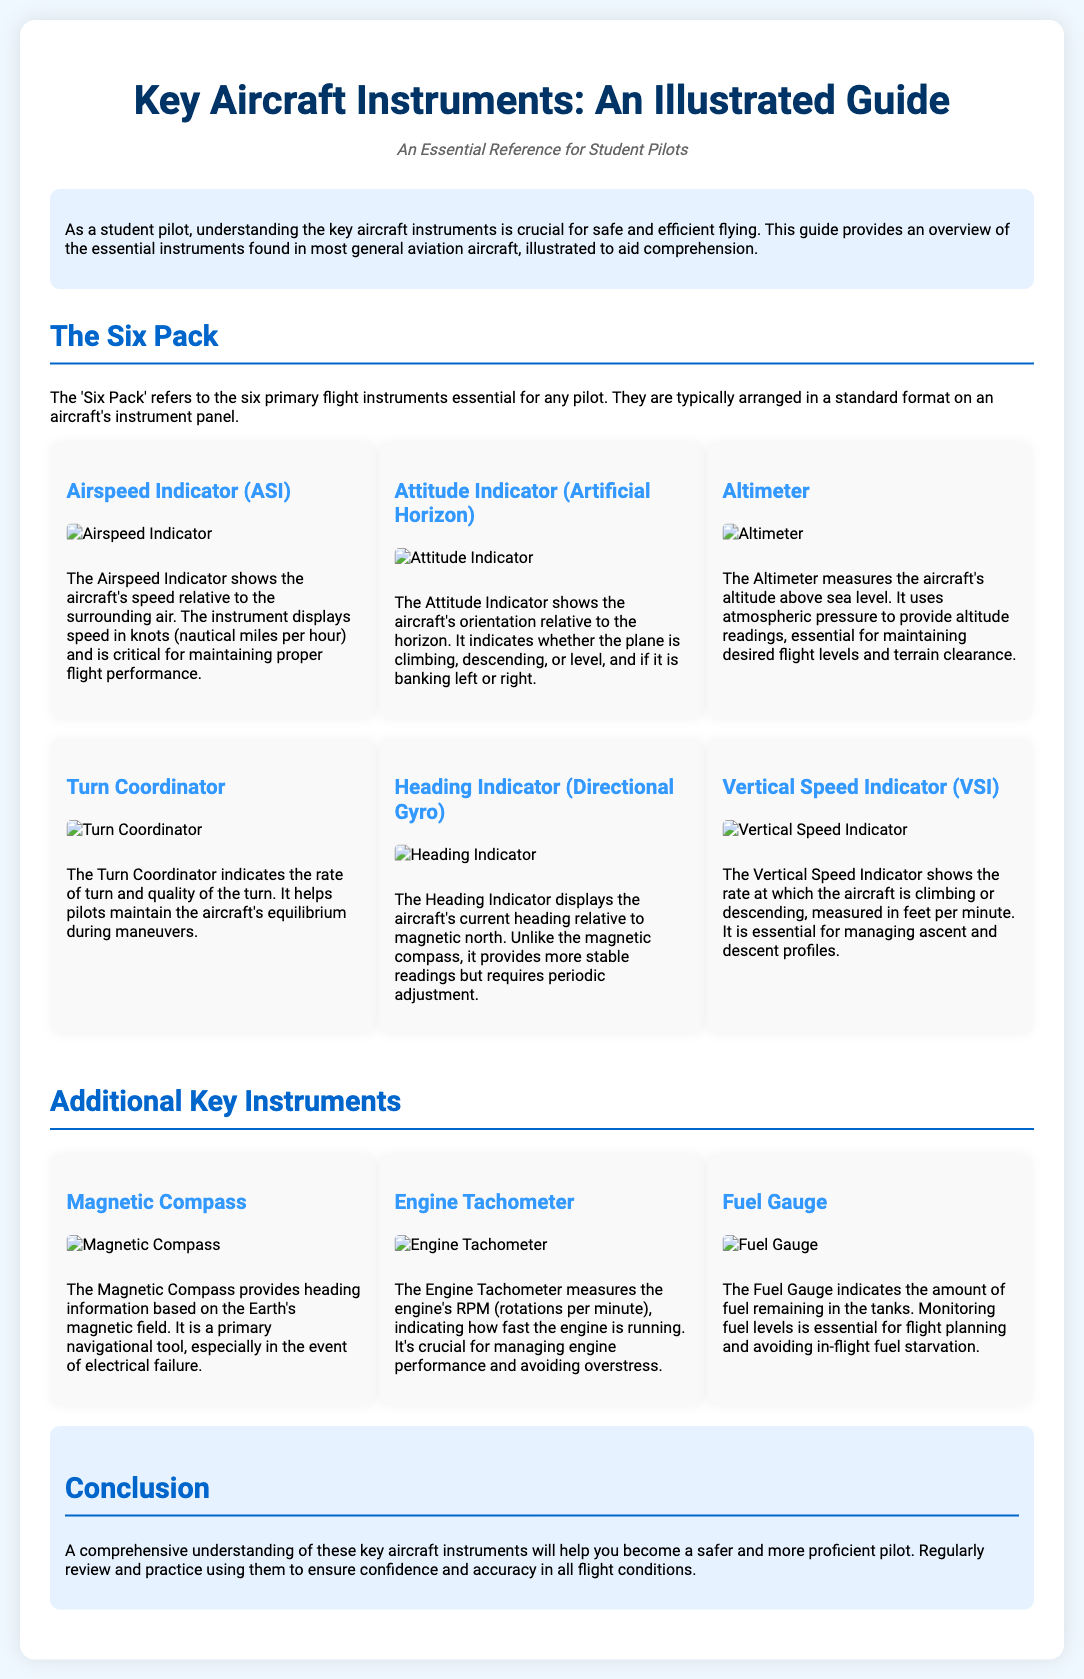What are the six primary flight instruments referred to as? The 'Six Pack' refers to the six primary flight instruments essential for any pilot.
Answer: Six Pack What does the Airspeed Indicator measure? The Airspeed Indicator shows the aircraft's speed relative to the surrounding air.
Answer: Speed Which instrument indicates the aircraft's orientation relative to the horizon? The Attitude Indicator shows the aircraft's orientation relative to the horizon.
Answer: Attitude Indicator What unit does the Altimeter use to measure altitude? The Altimeter uses atmospheric pressure to provide altitude readings, essential for maintaining desired flight levels.
Answer: Atmospheric pressure What does the Vertical Speed Indicator display? The Vertical Speed Indicator shows the rate at which the aircraft is climbing or descending.
Answer: Climbing or descending What additional instrument provides heading information based on the Earth's magnetic field? The Magnetic Compass provides heading information based on the Earth's magnetic field.
Answer: Magnetic Compass Which instrument measures the engine's RPM? The Engine Tachometer measures the engine's RPM (rotations per minute).
Answer: Engine Tachometer What is essential for flight planning and avoiding in-flight fuel starvation? Monitoring fuel levels is essential for flight planning and avoiding in-flight fuel starvation.
Answer: Fuel Gauge What is the main purpose of the Turn Coordinator? The Turn Coordinator indicates the rate of turn and quality of the turn.
Answer: Rate of turn and quality of the turn 